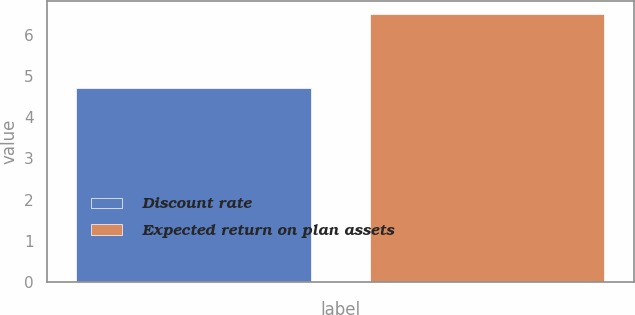<chart> <loc_0><loc_0><loc_500><loc_500><bar_chart><fcel>Discount rate<fcel>Expected return on plan assets<nl><fcel>4.7<fcel>6.5<nl></chart> 